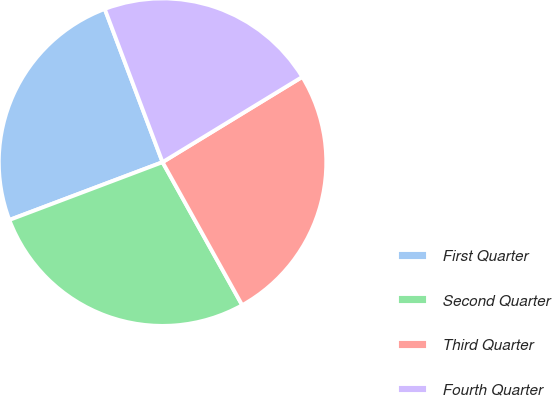<chart> <loc_0><loc_0><loc_500><loc_500><pie_chart><fcel>First Quarter<fcel>Second Quarter<fcel>Third Quarter<fcel>Fourth Quarter<nl><fcel>25.0%<fcel>27.34%<fcel>25.63%<fcel>22.02%<nl></chart> 